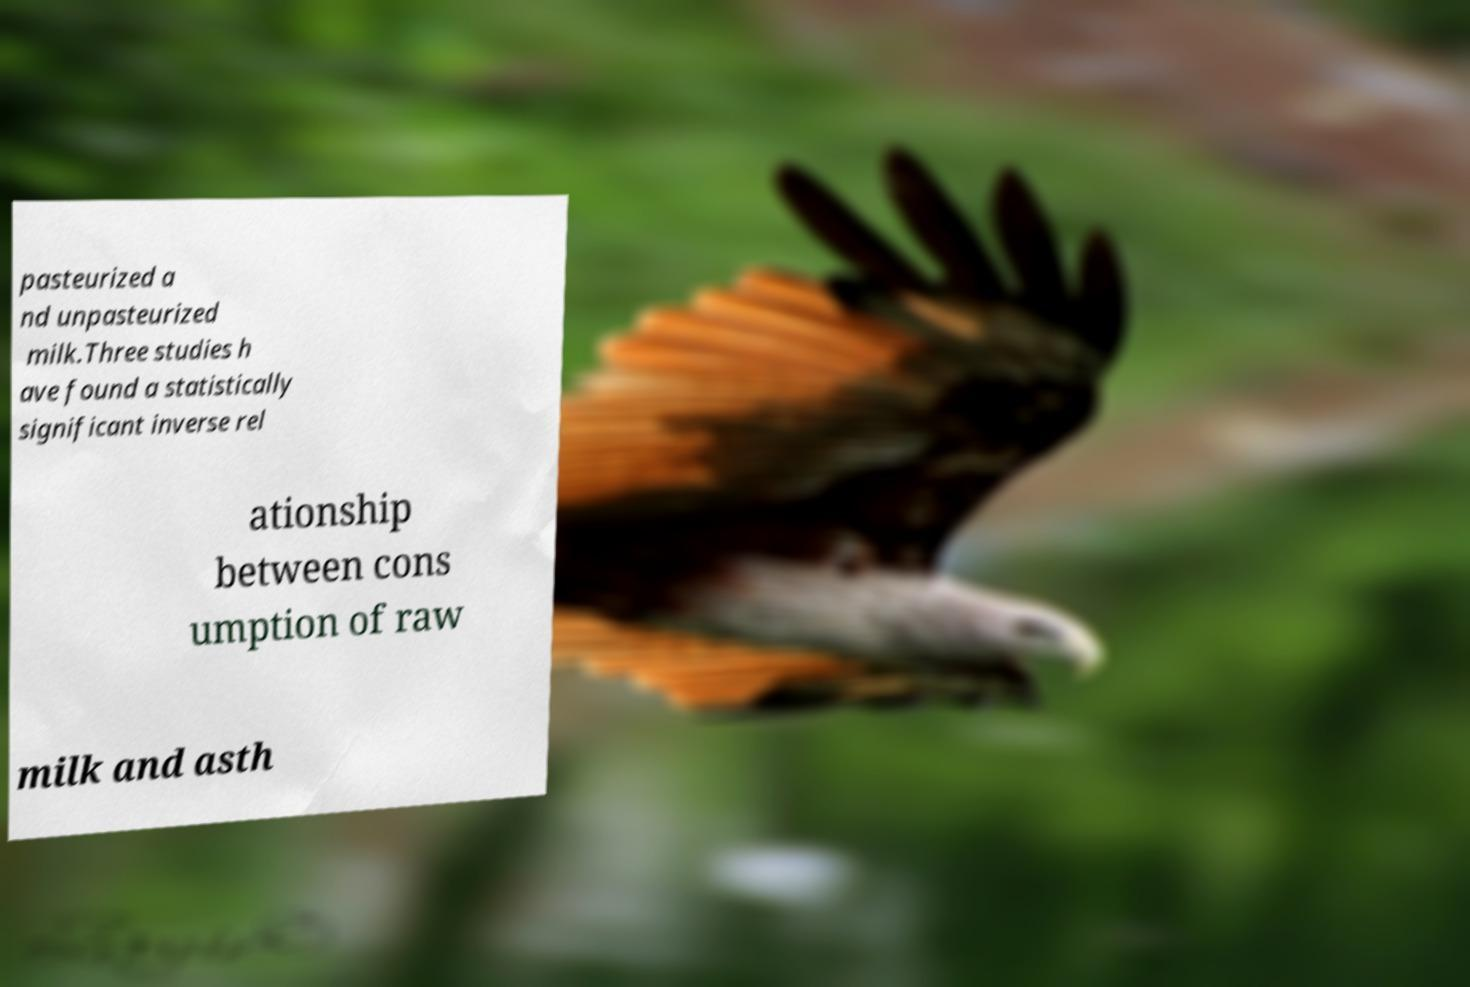There's text embedded in this image that I need extracted. Can you transcribe it verbatim? pasteurized a nd unpasteurized milk.Three studies h ave found a statistically significant inverse rel ationship between cons umption of raw milk and asth 